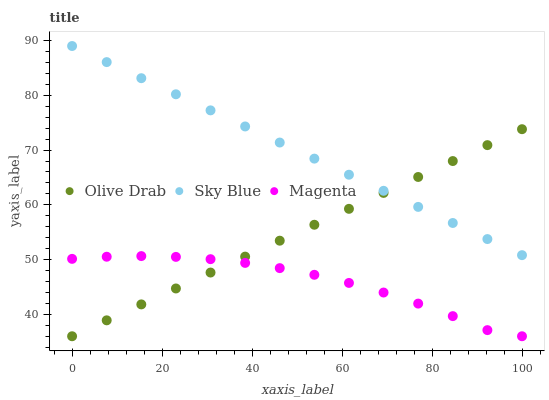Does Magenta have the minimum area under the curve?
Answer yes or no. Yes. Does Sky Blue have the maximum area under the curve?
Answer yes or no. Yes. Does Olive Drab have the minimum area under the curve?
Answer yes or no. No. Does Olive Drab have the maximum area under the curve?
Answer yes or no. No. Is Sky Blue the smoothest?
Answer yes or no. Yes. Is Magenta the roughest?
Answer yes or no. Yes. Is Olive Drab the smoothest?
Answer yes or no. No. Is Olive Drab the roughest?
Answer yes or no. No. Does Magenta have the lowest value?
Answer yes or no. Yes. Does Sky Blue have the highest value?
Answer yes or no. Yes. Does Olive Drab have the highest value?
Answer yes or no. No. Is Magenta less than Sky Blue?
Answer yes or no. Yes. Is Sky Blue greater than Magenta?
Answer yes or no. Yes. Does Olive Drab intersect Magenta?
Answer yes or no. Yes. Is Olive Drab less than Magenta?
Answer yes or no. No. Is Olive Drab greater than Magenta?
Answer yes or no. No. Does Magenta intersect Sky Blue?
Answer yes or no. No. 